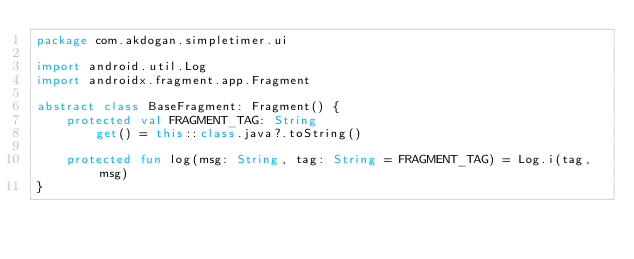Convert code to text. <code><loc_0><loc_0><loc_500><loc_500><_Kotlin_>package com.akdogan.simpletimer.ui

import android.util.Log
import androidx.fragment.app.Fragment

abstract class BaseFragment: Fragment() {
    protected val FRAGMENT_TAG: String
        get() = this::class.java?.toString()

    protected fun log(msg: String, tag: String = FRAGMENT_TAG) = Log.i(tag, msg)
}</code> 